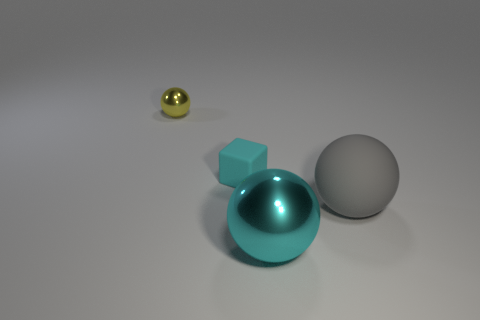Do the tiny yellow sphere and the small cube have the same material?
Provide a short and direct response. No. How many metal things are either small purple objects or things?
Give a very brief answer. 2. The rubber cube that is the same size as the yellow shiny ball is what color?
Your response must be concise. Cyan. What number of large cyan objects have the same shape as the small cyan matte thing?
Your response must be concise. 0. What number of cylinders are big rubber things or small yellow objects?
Offer a very short reply. 0. Do the metallic thing in front of the big gray matte sphere and the metallic thing behind the large gray rubber thing have the same shape?
Give a very brief answer. Yes. What is the material of the big gray thing?
Give a very brief answer. Rubber. What is the shape of the metallic thing that is the same color as the tiny matte object?
Ensure brevity in your answer.  Sphere. What number of matte things have the same size as the cyan rubber block?
Make the answer very short. 0. How many things are balls that are to the left of the gray matte thing or metal objects that are behind the small rubber thing?
Your response must be concise. 2. 